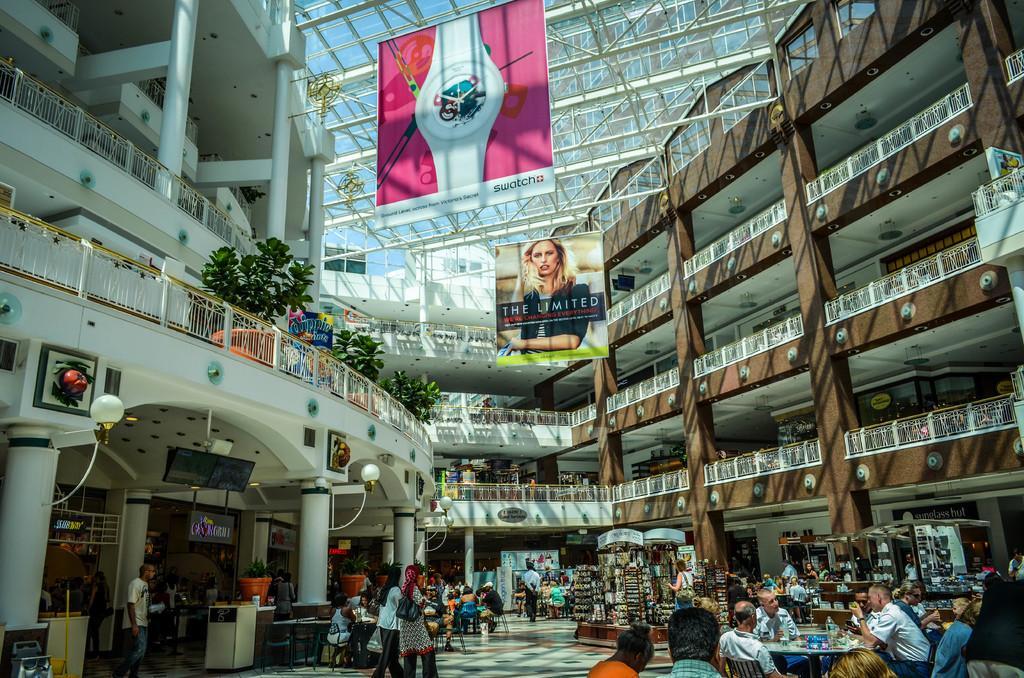In one or two sentences, can you explain what this image depicts? Here I can see a building. At the bottom of the image I can see few people are sitting on the chairs and few people are walking on the floor. There are many stalls. It is looking like a mall. Here I can see few pillars also. On the top I can see two banners which are hanging to a metal rod. On the top of the building I can see few plants which are placed beside the railing. 